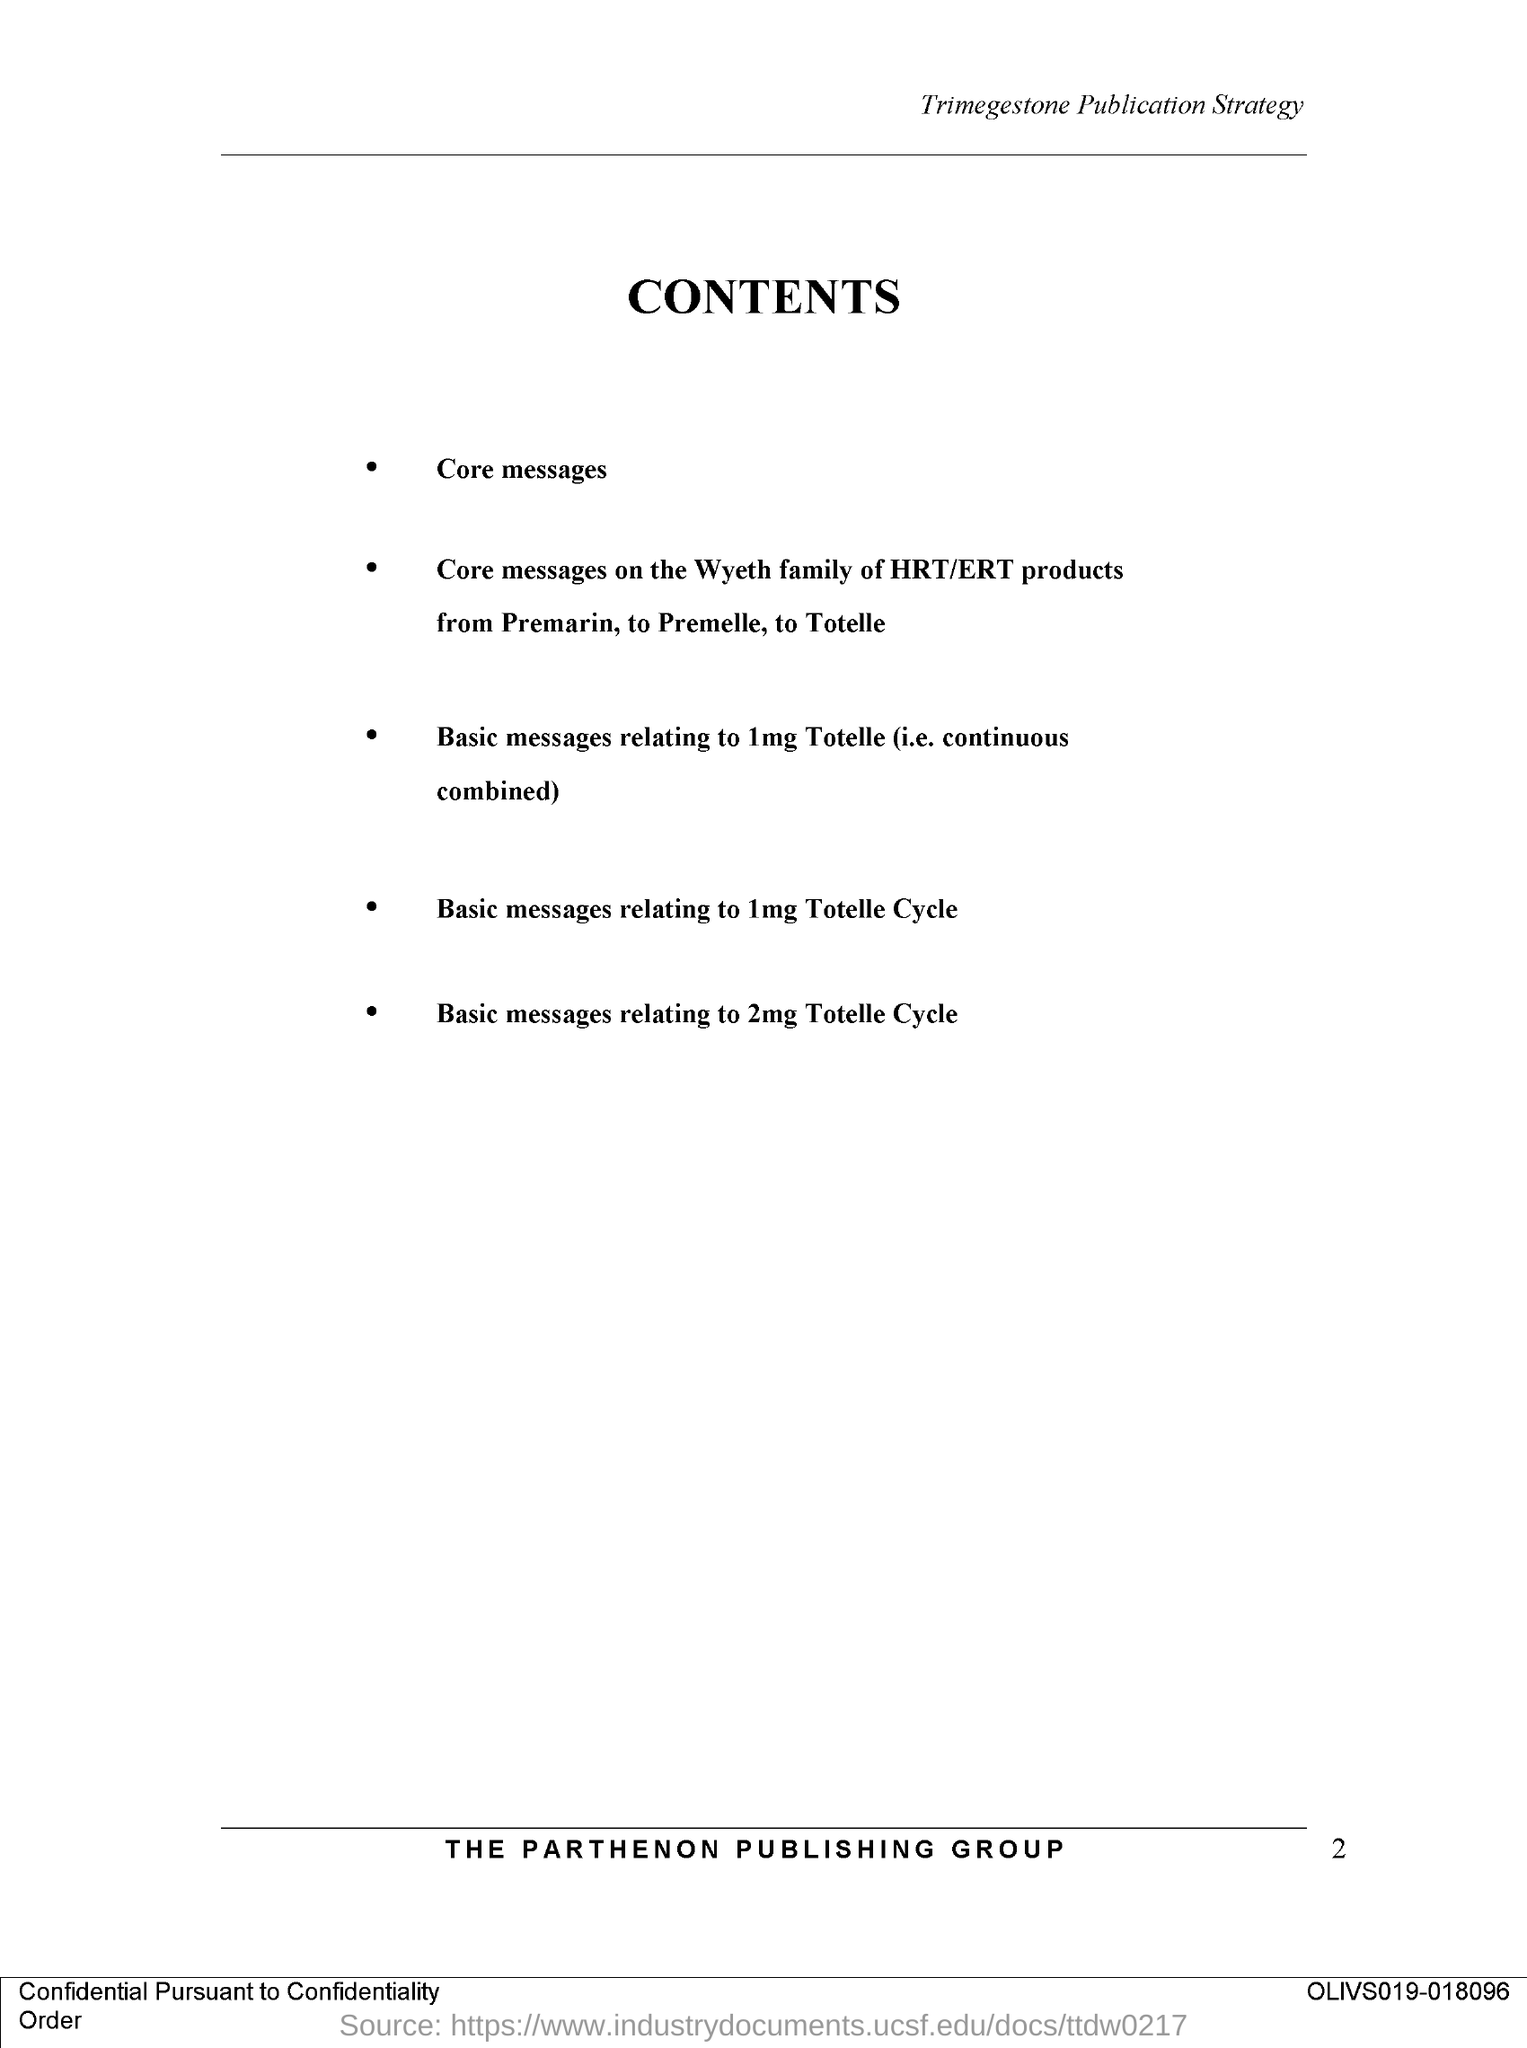What is the Title of the document?
Keep it short and to the point. Contents. What is the name of the publishing group?
Your answer should be compact. THE PARTHENON PUBLISHING GROUP. 